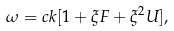Convert formula to latex. <formula><loc_0><loc_0><loc_500><loc_500>\omega = c k [ 1 + \xi F + \xi ^ { 2 } U ] ,</formula> 